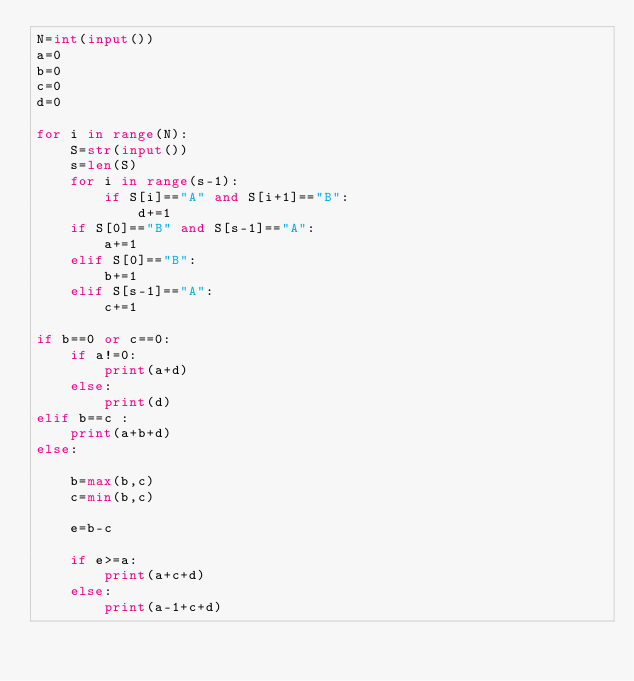Convert code to text. <code><loc_0><loc_0><loc_500><loc_500><_Python_>N=int(input())
a=0
b=0
c=0
d=0

for i in range(N):
    S=str(input())
    s=len(S)
    for i in range(s-1):
        if S[i]=="A" and S[i+1]=="B":
            d+=1
    if S[0]=="B" and S[s-1]=="A":
        a+=1
    elif S[0]=="B":
        b+=1
    elif S[s-1]=="A":
        c+=1

if b==0 or c==0:
    if a!=0:
        print(a+d)
    else:
        print(d)
elif b==c :
    print(a+b+d)
else:

    b=max(b,c)
    c=min(b,c)

    e=b-c

    if e>=a:
        print(a+c+d)
    else:
        print(a-1+c+d)
</code> 